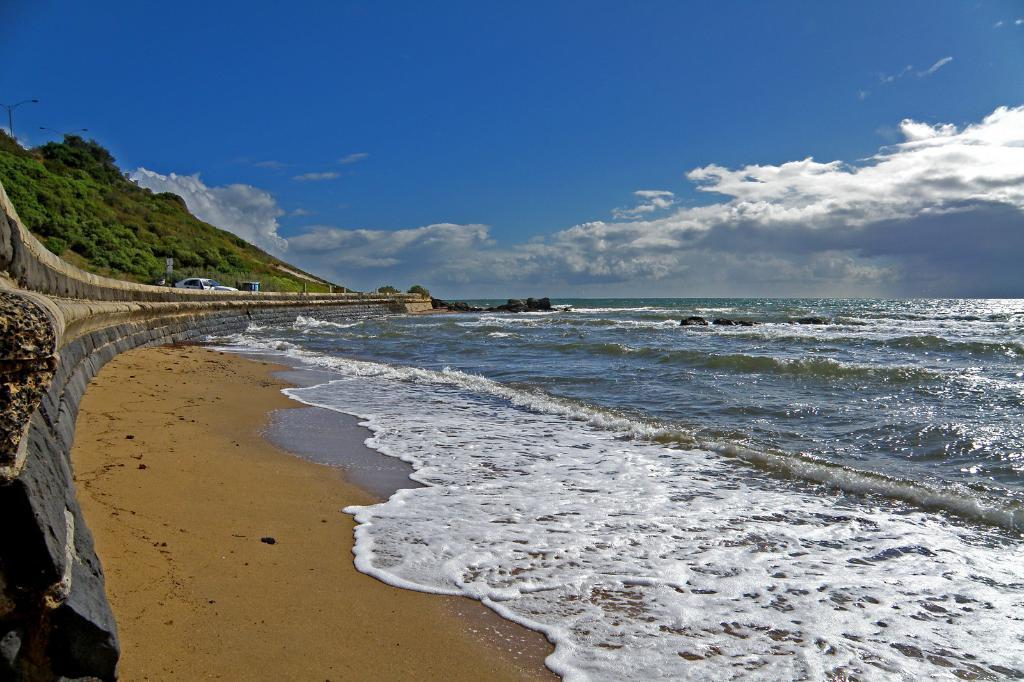What type of natural feature can be seen in the image? There is an ocean in the image. What other natural feature is present in the image? There is a mountain in the image. What type of terrain is visible in the image? There is sand in the image. What is visible above the natural features in the image? There is sky visible in the image. What can be seen in the sky in the image? There are clouds in the sky. What type of nose can be seen on the airplane in the image? There is no airplane present in the image, so there is no nose to observe. 